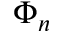Convert formula to latex. <formula><loc_0><loc_0><loc_500><loc_500>\Phi _ { n }</formula> 